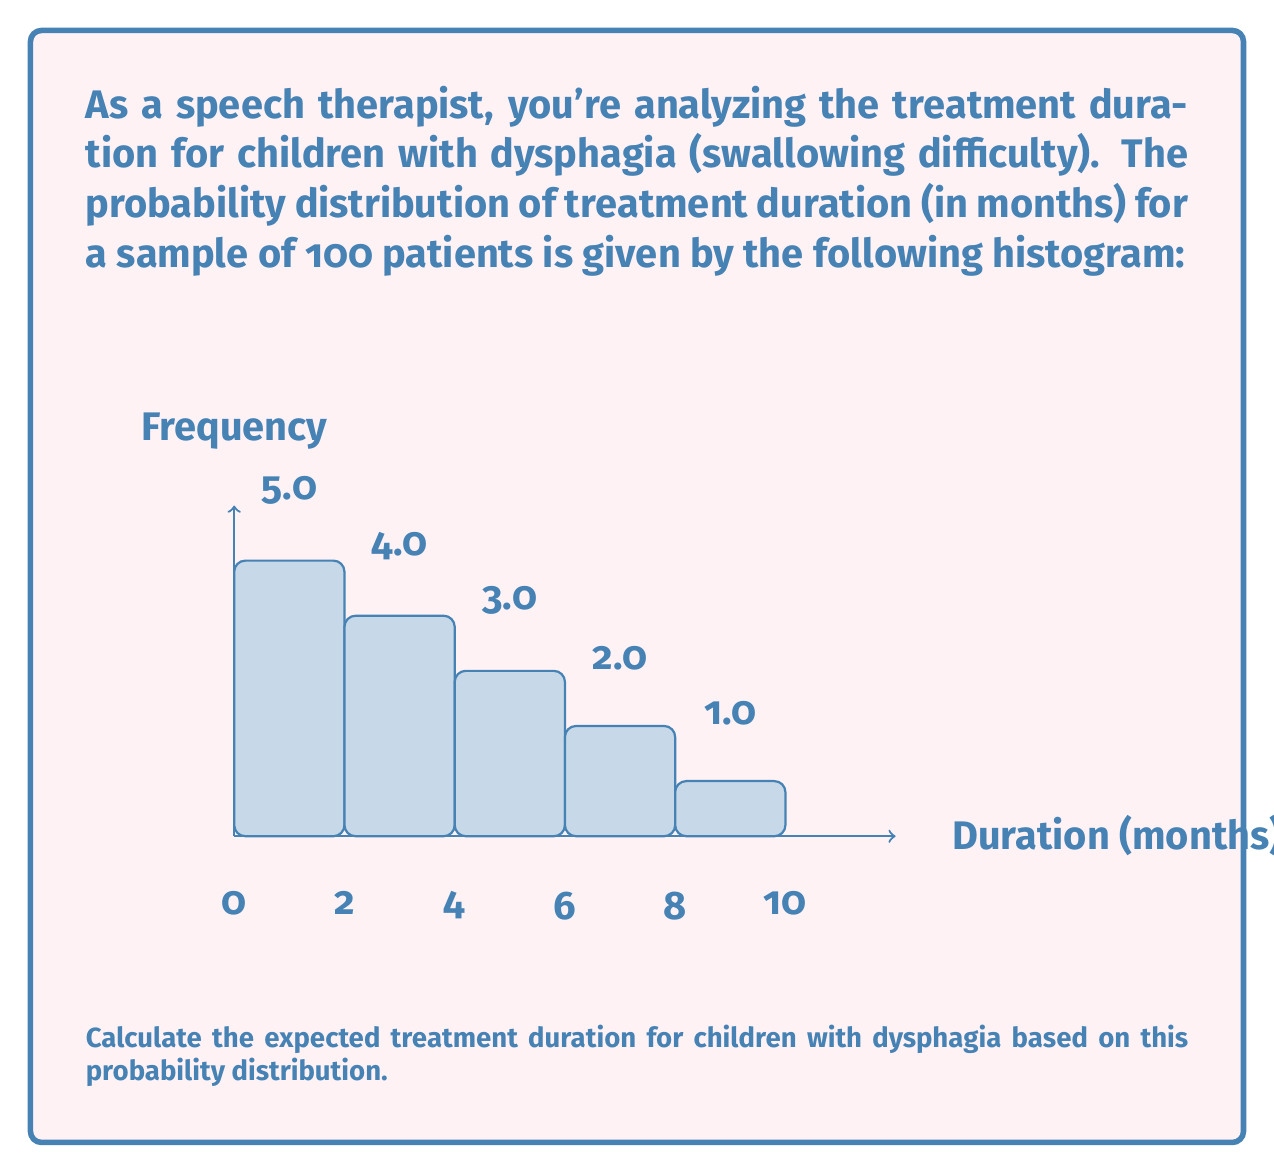Can you solve this math problem? To calculate the expected treatment duration, we need to follow these steps:

1) First, let's identify the probability for each duration interval:

   $P(0-2 \text{ months}) = 5/100 = 0.05$
   $P(2-4 \text{ months}) = 4/100 = 0.04$
   $P(4-6 \text{ months}) = 3/100 = 0.03$
   $P(6-8 \text{ months}) = 2/100 = 0.02$
   $P(8-10 \text{ months}) = 1/100 = 0.01$

2) Now, we need to calculate the midpoint of each interval:

   $0-2 \text{ months}: 1 \text{ month}$
   $2-4 \text{ months}: 3 \text{ months}$
   $4-6 \text{ months}: 5 \text{ months}$
   $6-8 \text{ months}: 7 \text{ months}$
   $8-10 \text{ months}: 9 \text{ months}$

3) The expected value is calculated by multiplying each midpoint by its probability and summing the results:

   $E(X) = \sum_{i=1}^{n} x_i \cdot P(X = x_i)$

   $E(X) = 1 \cdot 0.05 + 3 \cdot 0.04 + 5 \cdot 0.03 + 7 \cdot 0.02 + 9 \cdot 0.01$

4) Let's compute this:

   $E(X) = 0.05 + 0.12 + 0.15 + 0.14 + 0.09 = 0.55$

5) Therefore, the expected treatment duration is 0.55 months.

However, note that this result seems unusually low given the distribution. This is because we calculated the expected value using the frequencies as probabilities, which don't sum to 1. To correct this, we should normalize the frequencies:

6) Total frequency: $5 + 4 + 3 + 2 + 1 = 15$

7) Corrected probabilities:
   
   $P(0-2 \text{ months}) = 5/15 = 1/3$
   $P(2-4 \text{ months}) = 4/15$
   $P(4-6 \text{ months}) = 1/5$
   $P(6-8 \text{ months}) = 2/15$
   $P(8-10 \text{ months}) = 1/15$

8) Recalculating the expected value:

   $E(X) = 1 \cdot \frac{1}{3} + 3 \cdot \frac{4}{15} + 5 \cdot \frac{1}{5} + 7 \cdot \frac{2}{15} + 9 \cdot \frac{1}{15}$

   $E(X) = \frac{1}{3} + \frac{4}{5} + 1 + \frac{14}{15} + \frac{3}{5} = 3.67$
Answer: 3.67 months 